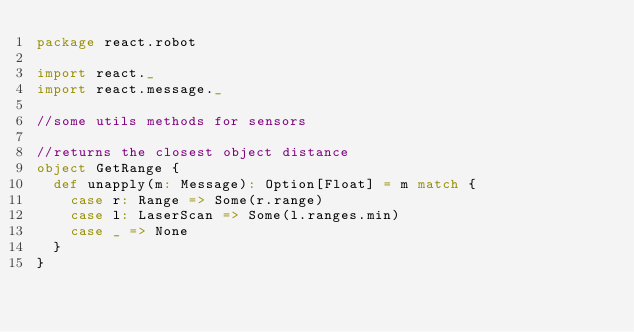Convert code to text. <code><loc_0><loc_0><loc_500><loc_500><_Scala_>package react.robot

import react._
import react.message._

//some utils methods for sensors

//returns the closest object distance
object GetRange {
  def unapply(m: Message): Option[Float] = m match {
    case r: Range => Some(r.range)
    case l: LaserScan => Some(l.ranges.min)
    case _ => None
  }
}
</code> 